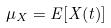<formula> <loc_0><loc_0><loc_500><loc_500>\mu _ { X } = E [ X ( t ) ]</formula> 